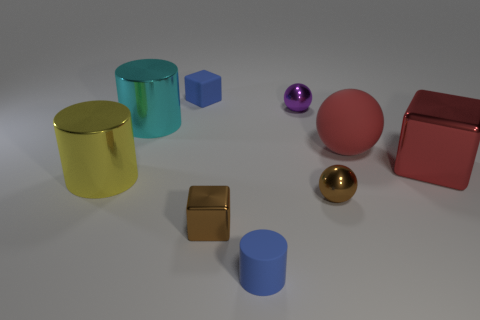It looks like there are a variety of textures in this scene. Could you elaborate on the different finishes of these objects? Certainly! The scene showcases objects with diverse textures. The golden and purple spheres have a high-gloss finish, reflecting light vividly which gives them a shiny appearance. The red and mustard cylinders have a satin-like texture, less reflective but still smooth and sleek. The blue cube, in contrast, has more of a matte finish, absorbing light and limiting reflection, thus providing a softer visual effect.  How does lighting affect the appearance of these objects? The lighting plays a crucial role in defining the appearance of these objects. It enhances their colors, creates distinct shadows, and reflects differently on each surface texture. The glossy objects exhibit bright highlights and sharp caustics, while the matte surfaces show diffused reflections and subtle shadows, providing a rich depth and dimensionality to the image. 